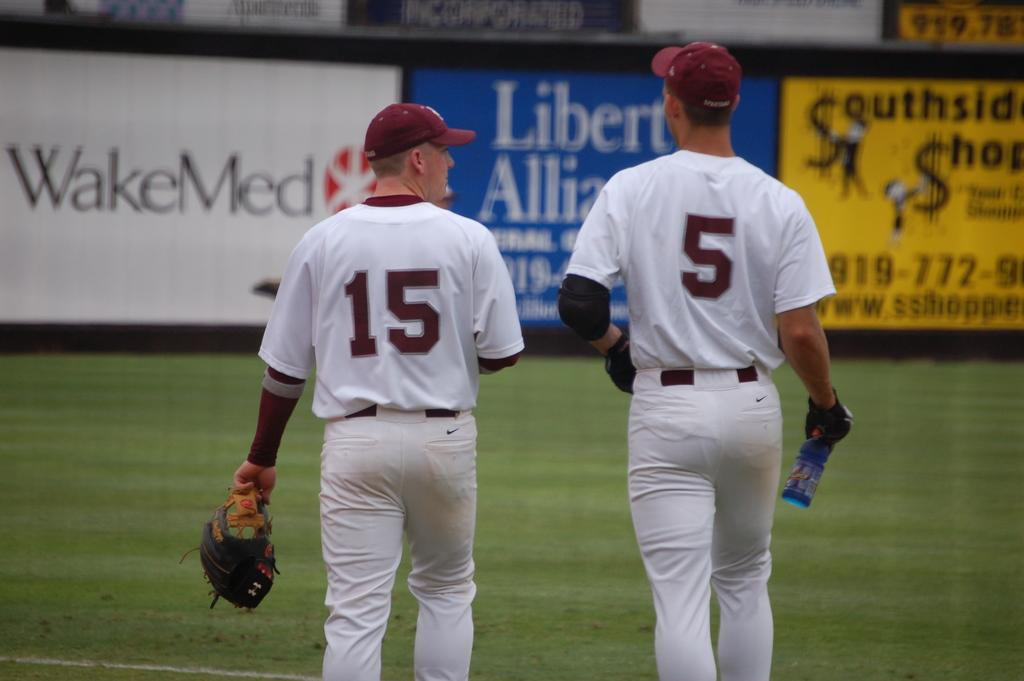<image>
Share a concise interpretation of the image provided. WakeMed is being advertised on the banner on the back wall. 